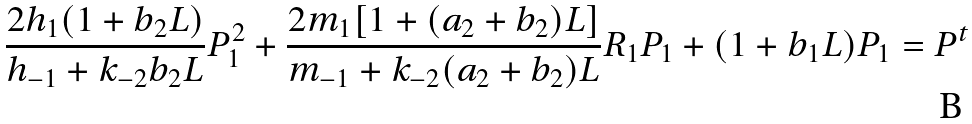<formula> <loc_0><loc_0><loc_500><loc_500>\frac { 2 h _ { 1 } ( 1 + b _ { 2 } L ) } { h _ { - 1 } + k _ { - 2 } b _ { 2 } L } P _ { 1 } ^ { 2 } + \frac { 2 m _ { 1 } [ 1 + ( a _ { 2 } + b _ { 2 } ) L ] } { m _ { - 1 } + k _ { - 2 } ( a _ { 2 } + b _ { 2 } ) L } R _ { 1 } P _ { 1 } + ( 1 + b _ { 1 } L ) P _ { 1 } = P ^ { t }</formula> 